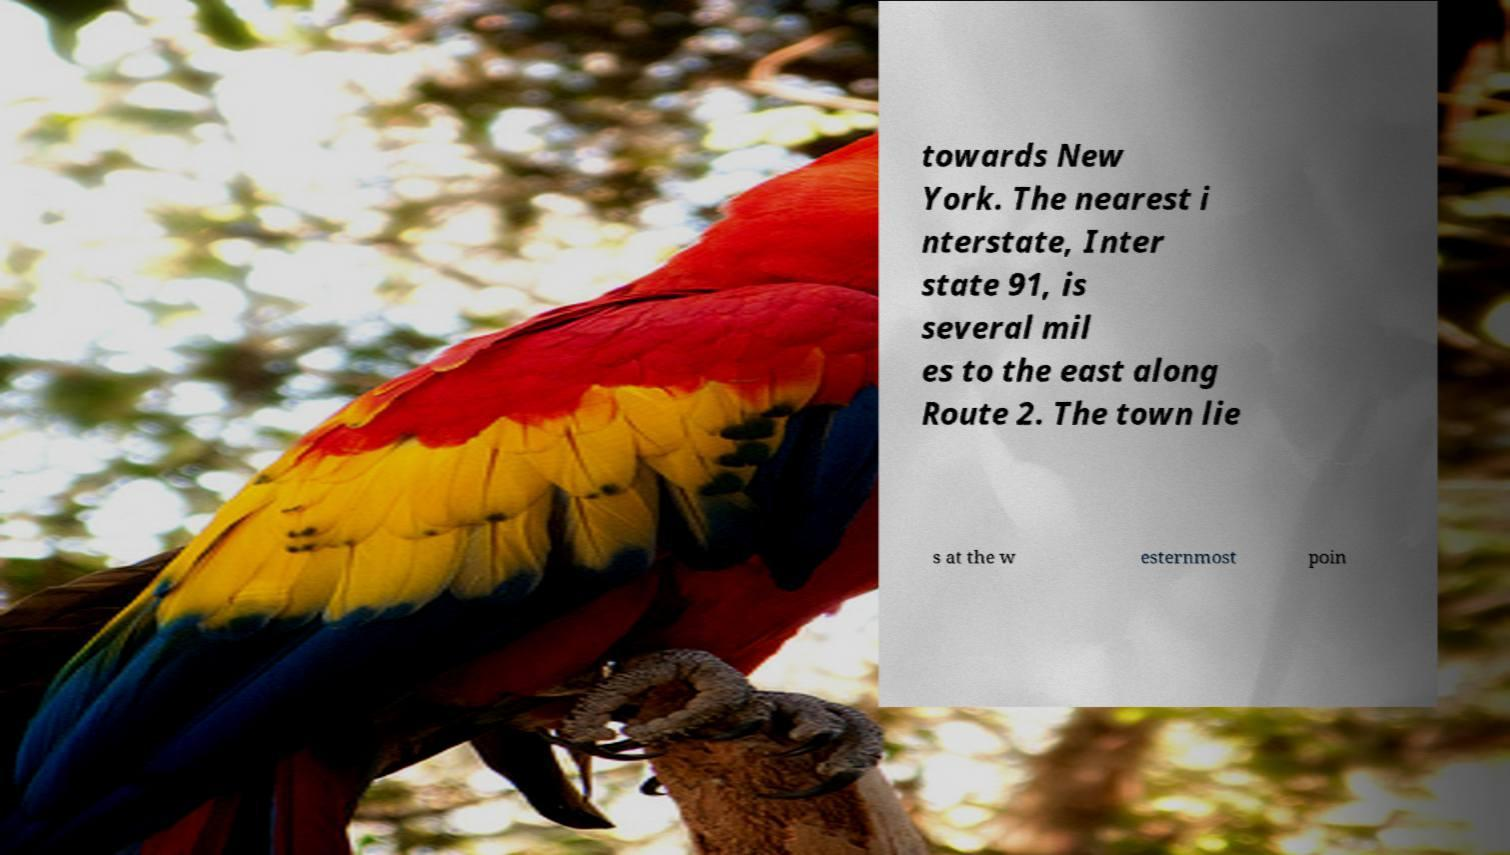What messages or text are displayed in this image? I need them in a readable, typed format. towards New York. The nearest i nterstate, Inter state 91, is several mil es to the east along Route 2. The town lie s at the w esternmost poin 